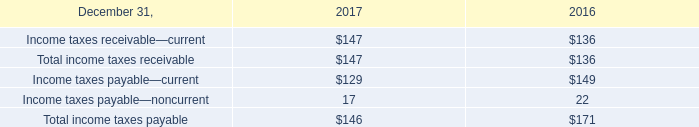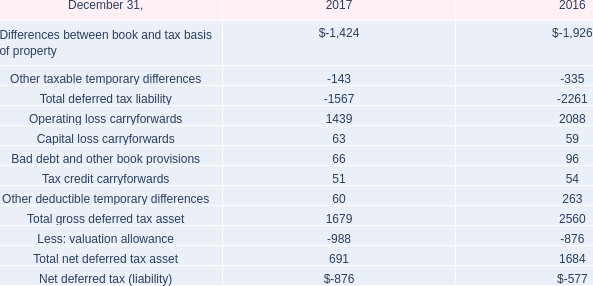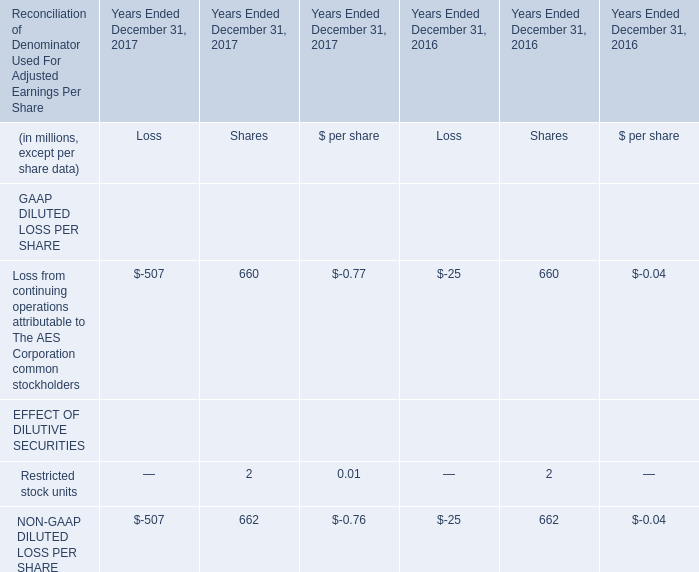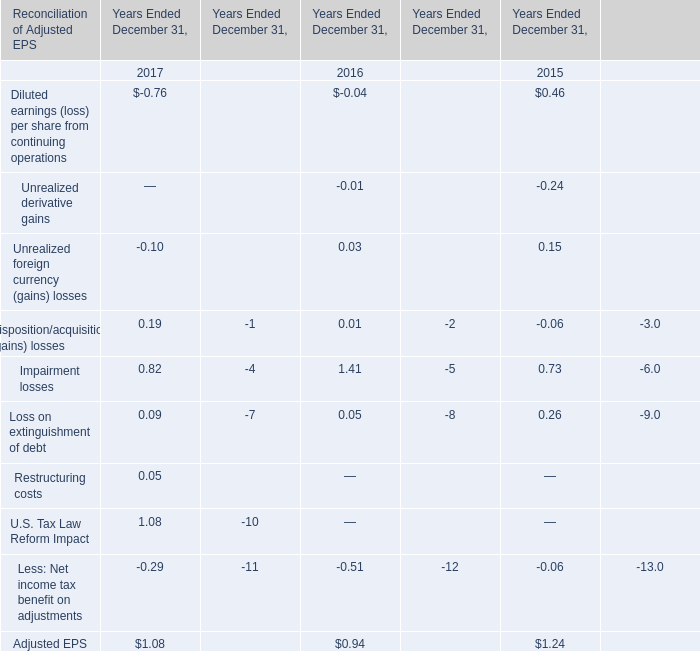Which year is Loss from continuing operations attributable to The AES Corporation common stockholders the most? 
Answer: 2016. 